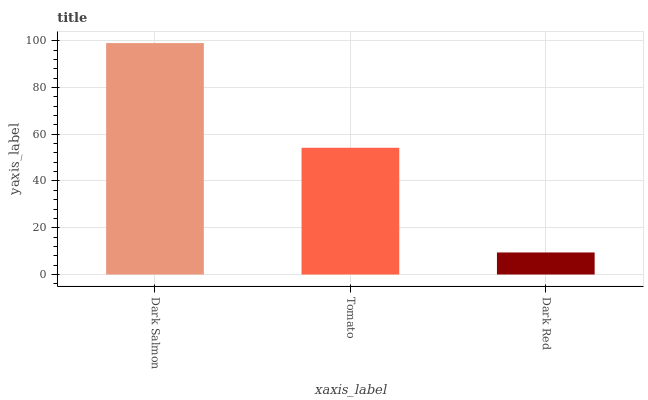Is Dark Red the minimum?
Answer yes or no. Yes. Is Dark Salmon the maximum?
Answer yes or no. Yes. Is Tomato the minimum?
Answer yes or no. No. Is Tomato the maximum?
Answer yes or no. No. Is Dark Salmon greater than Tomato?
Answer yes or no. Yes. Is Tomato less than Dark Salmon?
Answer yes or no. Yes. Is Tomato greater than Dark Salmon?
Answer yes or no. No. Is Dark Salmon less than Tomato?
Answer yes or no. No. Is Tomato the high median?
Answer yes or no. Yes. Is Tomato the low median?
Answer yes or no. Yes. Is Dark Red the high median?
Answer yes or no. No. Is Dark Salmon the low median?
Answer yes or no. No. 